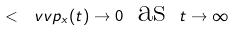Convert formula to latex. <formula><loc_0><loc_0><loc_500><loc_500>< { \ v v p _ { x } ( t ) } \to 0 \, \ \text {as} \, \ t \to \infty</formula> 